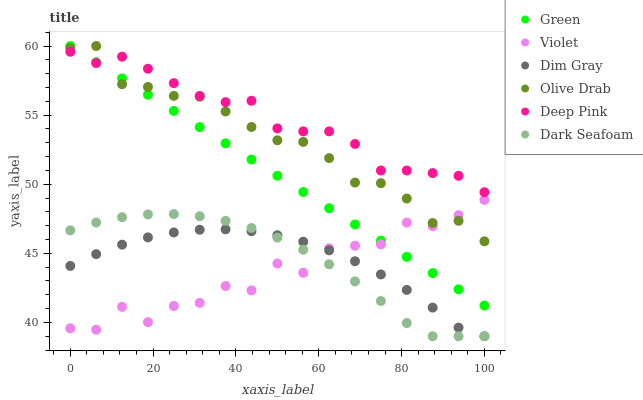Does Violet have the minimum area under the curve?
Answer yes or no. Yes. Does Deep Pink have the maximum area under the curve?
Answer yes or no. Yes. Does Dark Seafoam have the minimum area under the curve?
Answer yes or no. No. Does Dark Seafoam have the maximum area under the curve?
Answer yes or no. No. Is Green the smoothest?
Answer yes or no. Yes. Is Violet the roughest?
Answer yes or no. Yes. Is Dark Seafoam the smoothest?
Answer yes or no. No. Is Dark Seafoam the roughest?
Answer yes or no. No. Does Dim Gray have the lowest value?
Answer yes or no. Yes. Does Deep Pink have the lowest value?
Answer yes or no. No. Does Olive Drab have the highest value?
Answer yes or no. Yes. Does Dark Seafoam have the highest value?
Answer yes or no. No. Is Violet less than Deep Pink?
Answer yes or no. Yes. Is Deep Pink greater than Dark Seafoam?
Answer yes or no. Yes. Does Violet intersect Green?
Answer yes or no. Yes. Is Violet less than Green?
Answer yes or no. No. Is Violet greater than Green?
Answer yes or no. No. Does Violet intersect Deep Pink?
Answer yes or no. No. 